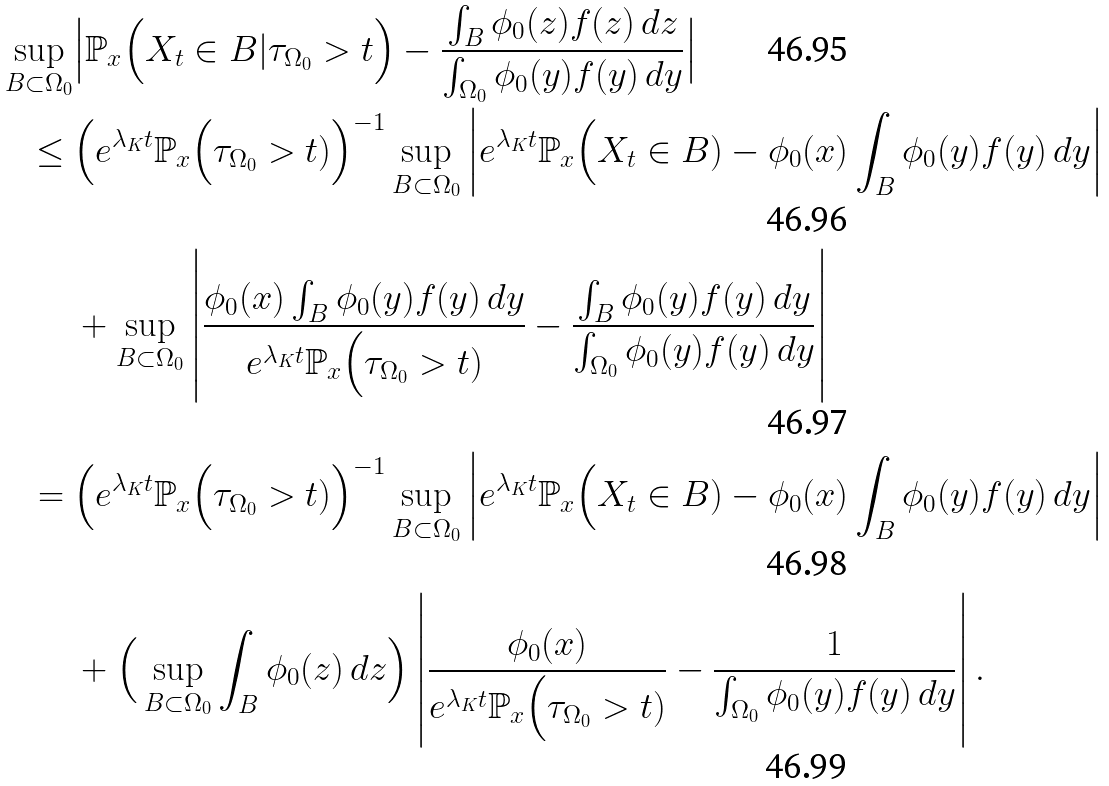<formula> <loc_0><loc_0><loc_500><loc_500>\sup _ { B \subset \Omega _ { 0 } } & \Big | \mathbb { P } _ { x } \Big ( X _ { t } \in B | \tau _ { \Omega _ { 0 } } > t \Big ) - \frac { \int _ { B } \phi _ { 0 } ( z ) f ( z ) \, d z } { \int _ { \Omega _ { 0 } } \phi _ { 0 } ( y ) f ( y ) \, d y } \Big | \\ \leq \ & \Big ( e ^ { \lambda _ { K } t } \mathbb { P } _ { x } \Big ( \tau _ { \Omega _ { 0 } } > t ) \Big ) ^ { - 1 } \sup _ { B \subset \Omega _ { 0 } } \left | e ^ { \lambda _ { K } t } \mathbb { P } _ { x } \Big ( X _ { t } \in B ) - \phi _ { 0 } ( x ) \int _ { B } \phi _ { 0 } ( y ) f ( y ) \, d y \right | \\ & + \sup _ { B \subset \Omega _ { 0 } } \left | \frac { \phi _ { 0 } ( x ) \int _ { B } \phi _ { 0 } ( y ) f ( y ) \, d y } { e ^ { \lambda _ { K } t } \mathbb { P } _ { x } \Big ( \tau _ { \Omega _ { 0 } } > t ) } - \frac { \int _ { B } \phi _ { 0 } ( y ) f ( y ) \, d y } { \int _ { \Omega _ { 0 } } \phi _ { 0 } ( y ) f ( y ) \, d y } \right | \\ = \ & \Big ( e ^ { \lambda _ { K } t } \mathbb { P } _ { x } \Big ( \tau _ { \Omega _ { 0 } } > t ) \Big ) ^ { - 1 } \sup _ { B \subset \Omega _ { 0 } } \left | e ^ { \lambda _ { K } t } \mathbb { P } _ { x } \Big ( X _ { t } \in B ) - \phi _ { 0 } ( x ) \int _ { B } \phi _ { 0 } ( y ) f ( y ) \, d y \right | \\ & + \Big ( \sup _ { B \subset \Omega _ { 0 } } \int _ { B } \phi _ { 0 } ( z ) \, d z \Big ) \left | \frac { \phi _ { 0 } ( x ) } { e ^ { \lambda _ { K } t } \mathbb { P } _ { x } \Big ( \tau _ { \Omega _ { 0 } } > t ) } - \frac { 1 } { \int _ { \Omega _ { 0 } } \phi _ { 0 } ( y ) f ( y ) \, d y } \right | .</formula> 